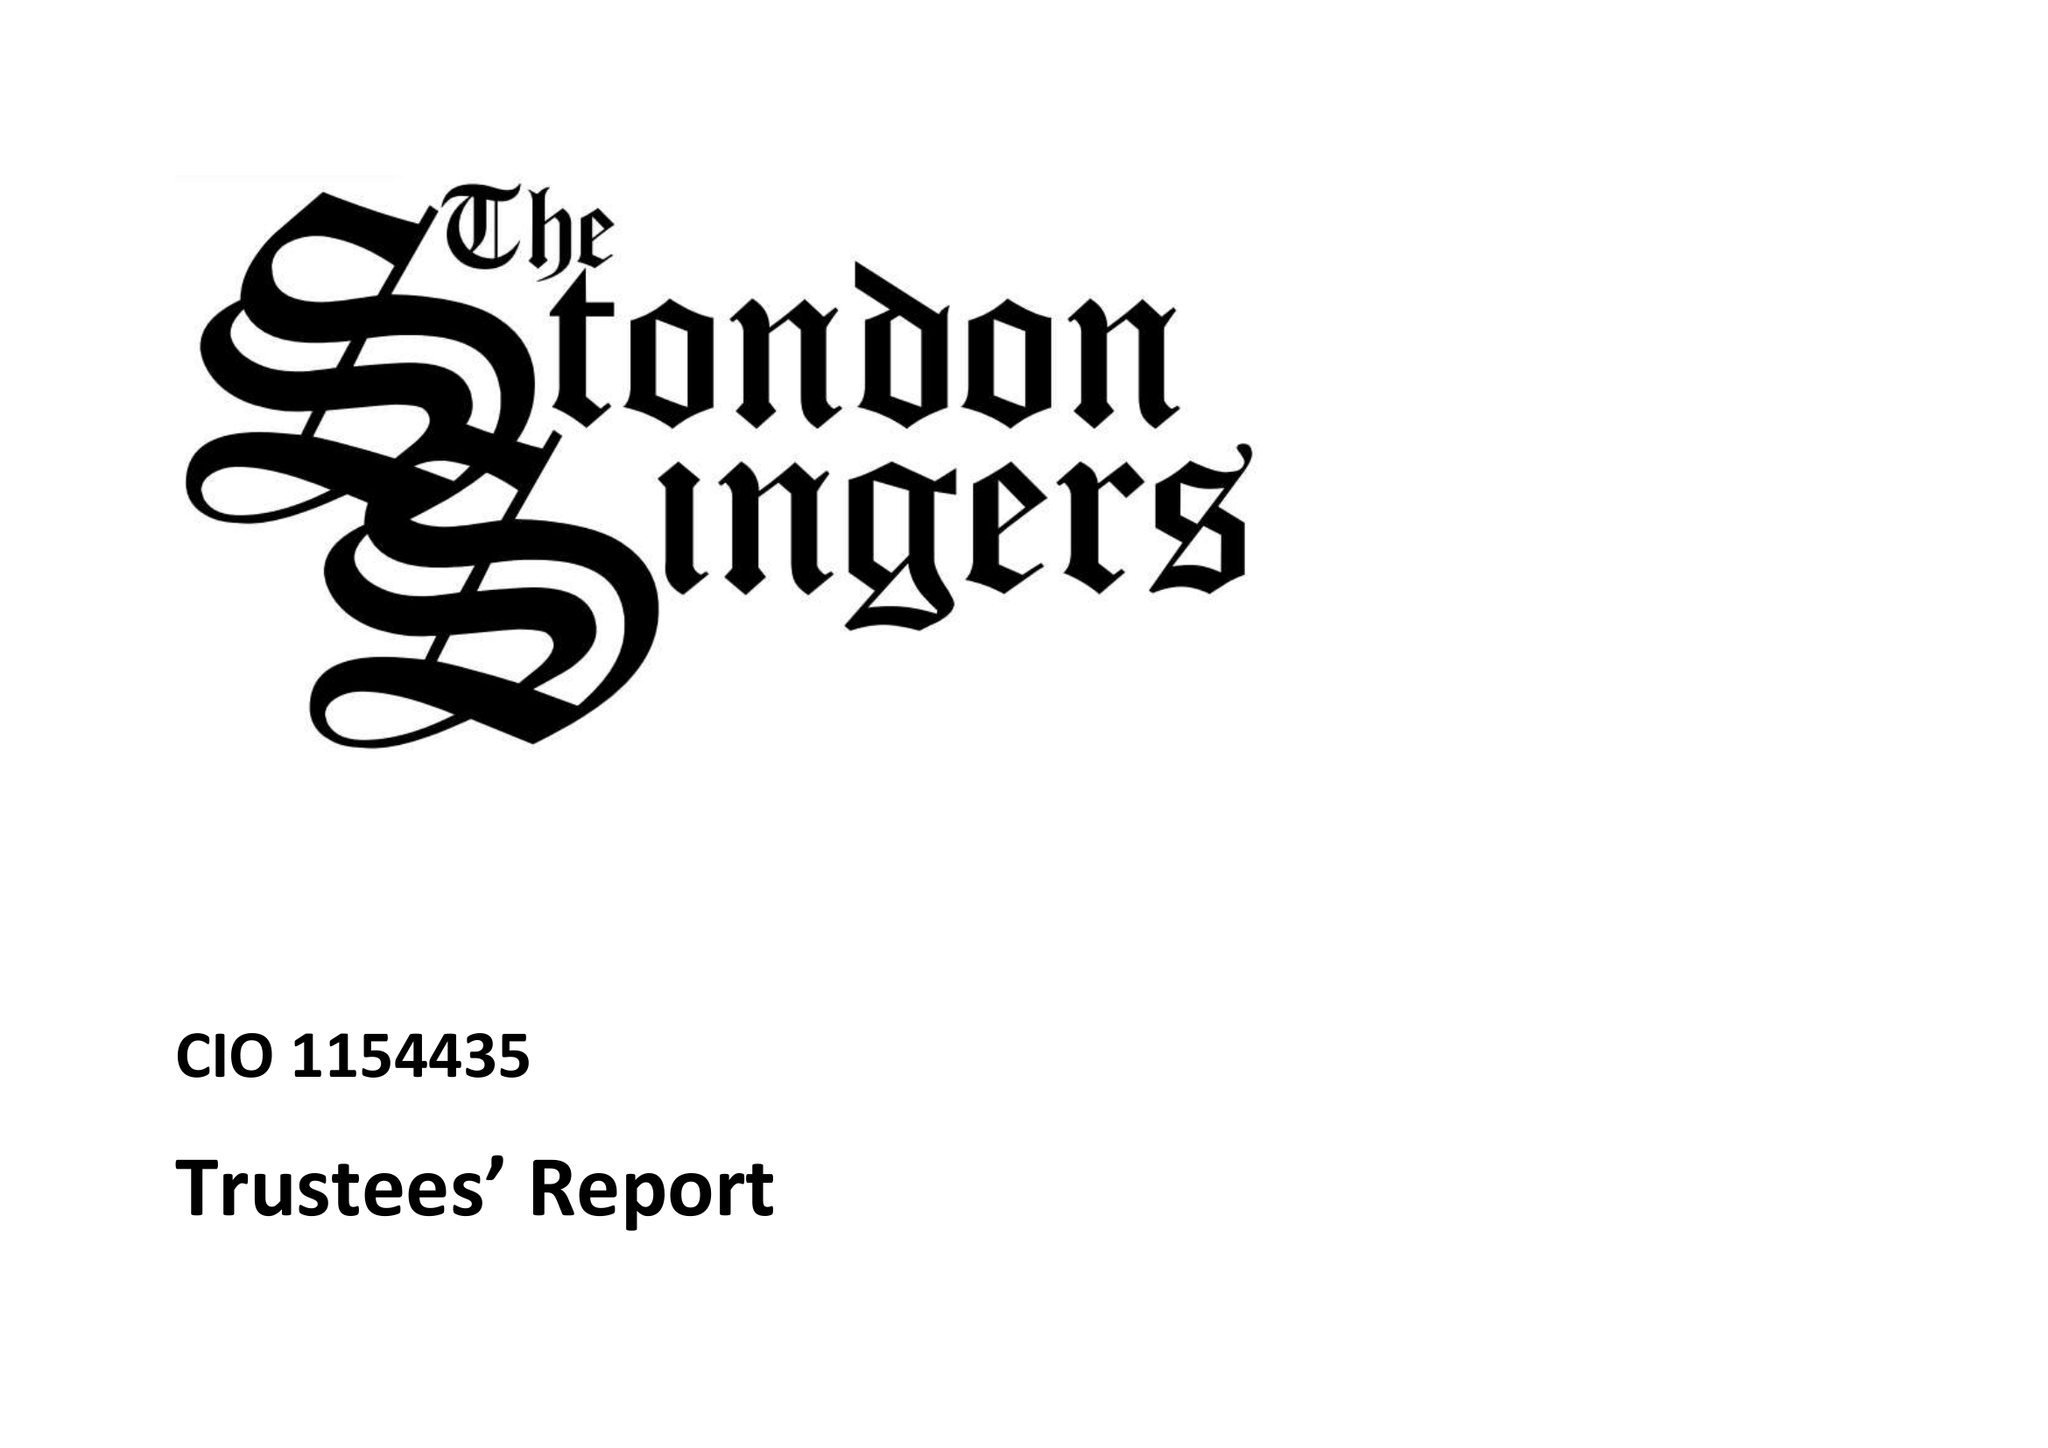What is the value for the spending_annually_in_british_pounds?
Answer the question using a single word or phrase. 9610.00 